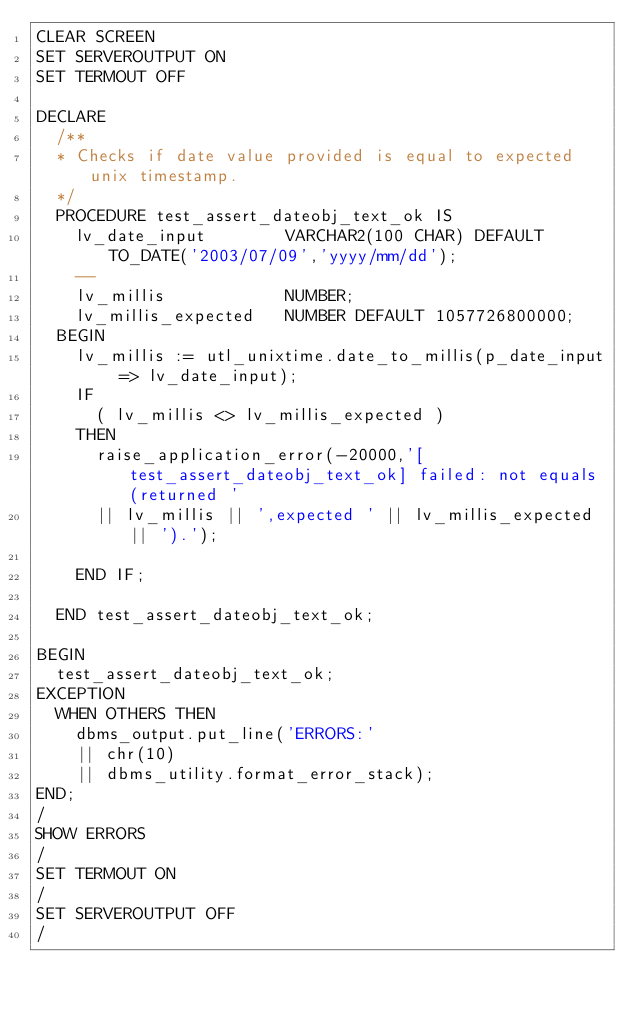<code> <loc_0><loc_0><loc_500><loc_500><_SQL_>CLEAR SCREEN
SET SERVEROUTPUT ON
SET TERMOUT OFF

DECLARE
  /**
  * Checks if date value provided is equal to expected unix timestamp.
  */
  PROCEDURE test_assert_dateobj_text_ok IS
    lv_date_input        VARCHAR2(100 CHAR) DEFAULT TO_DATE('2003/07/09','yyyy/mm/dd');
    --
    lv_millis            NUMBER;
    lv_millis_expected   NUMBER DEFAULT 1057726800000;
  BEGIN
    lv_millis := utl_unixtime.date_to_millis(p_date_input => lv_date_input);
    IF
      ( lv_millis <> lv_millis_expected )
    THEN
      raise_application_error(-20000,'[test_assert_dateobj_text_ok] failed: not equals (returned '
      || lv_millis || ',expected ' || lv_millis_expected || ').');

    END IF;

  END test_assert_dateobj_text_ok;

BEGIN
  test_assert_dateobj_text_ok;
EXCEPTION
  WHEN OTHERS THEN
    dbms_output.put_line('ERRORS:'
    || chr(10)
    || dbms_utility.format_error_stack);
END;
/
SHOW ERRORS
/
SET TERMOUT ON
/
SET SERVEROUTPUT OFF
/</code> 